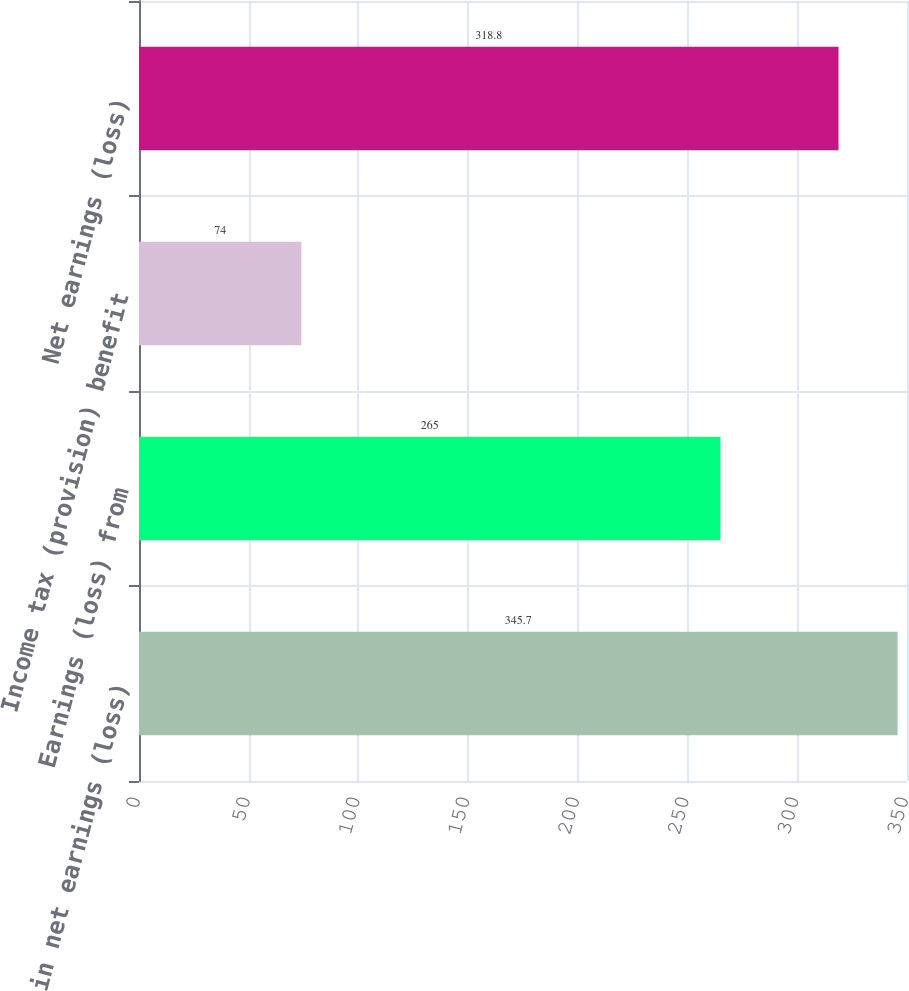Convert chart. <chart><loc_0><loc_0><loc_500><loc_500><bar_chart><fcel>Equity in net earnings (loss)<fcel>Earnings (loss) from<fcel>Income tax (provision) benefit<fcel>Net earnings (loss)<nl><fcel>345.7<fcel>265<fcel>74<fcel>318.8<nl></chart> 